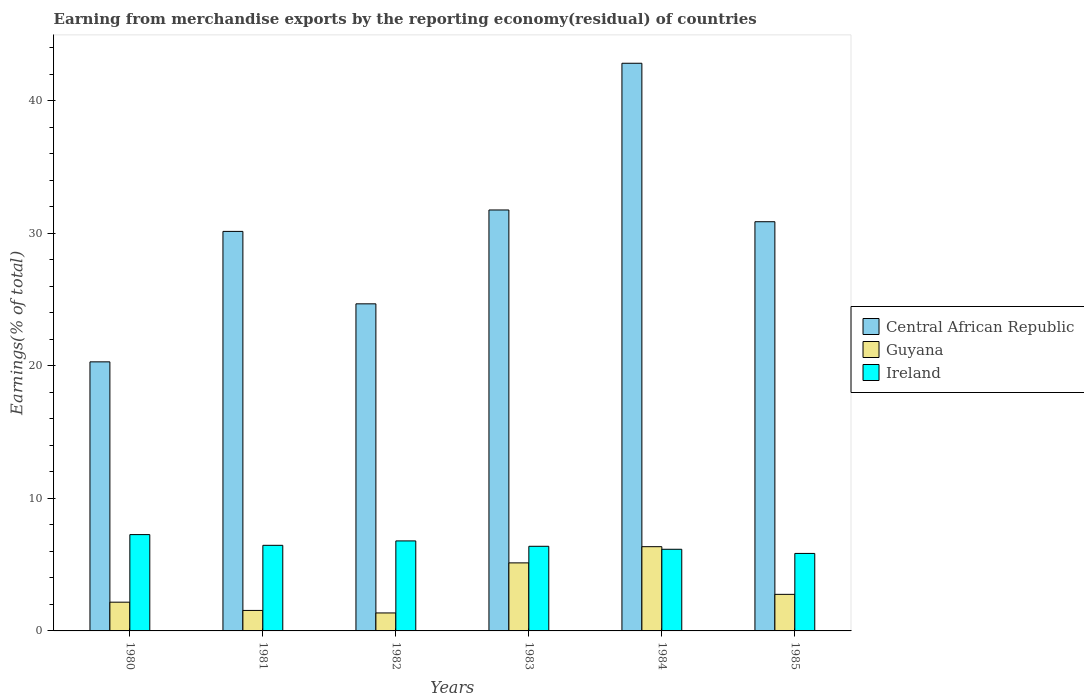Are the number of bars per tick equal to the number of legend labels?
Offer a very short reply. Yes. How many bars are there on the 4th tick from the right?
Provide a short and direct response. 3. In how many cases, is the number of bars for a given year not equal to the number of legend labels?
Keep it short and to the point. 0. What is the percentage of amount earned from merchandise exports in Ireland in 1983?
Your response must be concise. 6.38. Across all years, what is the maximum percentage of amount earned from merchandise exports in Ireland?
Make the answer very short. 7.27. Across all years, what is the minimum percentage of amount earned from merchandise exports in Ireland?
Offer a very short reply. 5.85. What is the total percentage of amount earned from merchandise exports in Ireland in the graph?
Offer a very short reply. 38.9. What is the difference between the percentage of amount earned from merchandise exports in Ireland in 1983 and that in 1984?
Provide a succinct answer. 0.22. What is the difference between the percentage of amount earned from merchandise exports in Guyana in 1985 and the percentage of amount earned from merchandise exports in Ireland in 1984?
Provide a short and direct response. -3.4. What is the average percentage of amount earned from merchandise exports in Guyana per year?
Ensure brevity in your answer.  3.22. In the year 1985, what is the difference between the percentage of amount earned from merchandise exports in Guyana and percentage of amount earned from merchandise exports in Ireland?
Provide a succinct answer. -3.09. In how many years, is the percentage of amount earned from merchandise exports in Central African Republic greater than 30 %?
Your answer should be very brief. 4. What is the ratio of the percentage of amount earned from merchandise exports in Central African Republic in 1983 to that in 1984?
Ensure brevity in your answer.  0.74. What is the difference between the highest and the second highest percentage of amount earned from merchandise exports in Ireland?
Your answer should be compact. 0.48. What is the difference between the highest and the lowest percentage of amount earned from merchandise exports in Ireland?
Your answer should be compact. 1.42. Is the sum of the percentage of amount earned from merchandise exports in Ireland in 1980 and 1983 greater than the maximum percentage of amount earned from merchandise exports in Central African Republic across all years?
Your answer should be compact. No. What does the 1st bar from the left in 1984 represents?
Provide a short and direct response. Central African Republic. What does the 2nd bar from the right in 1985 represents?
Provide a succinct answer. Guyana. How many years are there in the graph?
Your answer should be compact. 6. How many legend labels are there?
Provide a succinct answer. 3. What is the title of the graph?
Your response must be concise. Earning from merchandise exports by the reporting economy(residual) of countries. What is the label or title of the X-axis?
Offer a very short reply. Years. What is the label or title of the Y-axis?
Make the answer very short. Earnings(% of total). What is the Earnings(% of total) in Central African Republic in 1980?
Ensure brevity in your answer.  20.3. What is the Earnings(% of total) in Guyana in 1980?
Offer a terse response. 2.17. What is the Earnings(% of total) in Ireland in 1980?
Provide a short and direct response. 7.27. What is the Earnings(% of total) in Central African Republic in 1981?
Ensure brevity in your answer.  30.14. What is the Earnings(% of total) in Guyana in 1981?
Keep it short and to the point. 1.55. What is the Earnings(% of total) of Ireland in 1981?
Give a very brief answer. 6.46. What is the Earnings(% of total) in Central African Republic in 1982?
Your response must be concise. 24.67. What is the Earnings(% of total) of Guyana in 1982?
Keep it short and to the point. 1.36. What is the Earnings(% of total) in Ireland in 1982?
Your answer should be very brief. 6.79. What is the Earnings(% of total) in Central African Republic in 1983?
Give a very brief answer. 31.75. What is the Earnings(% of total) in Guyana in 1983?
Provide a succinct answer. 5.13. What is the Earnings(% of total) in Ireland in 1983?
Keep it short and to the point. 6.38. What is the Earnings(% of total) in Central African Republic in 1984?
Provide a succinct answer. 42.82. What is the Earnings(% of total) in Guyana in 1984?
Your response must be concise. 6.36. What is the Earnings(% of total) in Ireland in 1984?
Your response must be concise. 6.16. What is the Earnings(% of total) of Central African Republic in 1985?
Offer a very short reply. 30.87. What is the Earnings(% of total) of Guyana in 1985?
Your answer should be very brief. 2.76. What is the Earnings(% of total) of Ireland in 1985?
Provide a succinct answer. 5.85. Across all years, what is the maximum Earnings(% of total) of Central African Republic?
Keep it short and to the point. 42.82. Across all years, what is the maximum Earnings(% of total) in Guyana?
Provide a succinct answer. 6.36. Across all years, what is the maximum Earnings(% of total) of Ireland?
Offer a very short reply. 7.27. Across all years, what is the minimum Earnings(% of total) in Central African Republic?
Provide a succinct answer. 20.3. Across all years, what is the minimum Earnings(% of total) in Guyana?
Your answer should be compact. 1.36. Across all years, what is the minimum Earnings(% of total) of Ireland?
Keep it short and to the point. 5.85. What is the total Earnings(% of total) in Central African Republic in the graph?
Ensure brevity in your answer.  180.56. What is the total Earnings(% of total) of Guyana in the graph?
Offer a terse response. 19.32. What is the total Earnings(% of total) in Ireland in the graph?
Ensure brevity in your answer.  38.9. What is the difference between the Earnings(% of total) of Central African Republic in 1980 and that in 1981?
Provide a short and direct response. -9.84. What is the difference between the Earnings(% of total) in Guyana in 1980 and that in 1981?
Offer a very short reply. 0.62. What is the difference between the Earnings(% of total) of Ireland in 1980 and that in 1981?
Your response must be concise. 0.81. What is the difference between the Earnings(% of total) in Central African Republic in 1980 and that in 1982?
Keep it short and to the point. -4.38. What is the difference between the Earnings(% of total) in Guyana in 1980 and that in 1982?
Give a very brief answer. 0.81. What is the difference between the Earnings(% of total) in Ireland in 1980 and that in 1982?
Your response must be concise. 0.48. What is the difference between the Earnings(% of total) of Central African Republic in 1980 and that in 1983?
Your response must be concise. -11.46. What is the difference between the Earnings(% of total) in Guyana in 1980 and that in 1983?
Your response must be concise. -2.96. What is the difference between the Earnings(% of total) of Ireland in 1980 and that in 1983?
Provide a succinct answer. 0.88. What is the difference between the Earnings(% of total) in Central African Republic in 1980 and that in 1984?
Ensure brevity in your answer.  -22.52. What is the difference between the Earnings(% of total) of Guyana in 1980 and that in 1984?
Your response must be concise. -4.19. What is the difference between the Earnings(% of total) of Ireland in 1980 and that in 1984?
Give a very brief answer. 1.11. What is the difference between the Earnings(% of total) of Central African Republic in 1980 and that in 1985?
Keep it short and to the point. -10.57. What is the difference between the Earnings(% of total) of Guyana in 1980 and that in 1985?
Your response must be concise. -0.59. What is the difference between the Earnings(% of total) in Ireland in 1980 and that in 1985?
Your response must be concise. 1.42. What is the difference between the Earnings(% of total) of Central African Republic in 1981 and that in 1982?
Ensure brevity in your answer.  5.46. What is the difference between the Earnings(% of total) in Guyana in 1981 and that in 1982?
Your response must be concise. 0.19. What is the difference between the Earnings(% of total) in Ireland in 1981 and that in 1982?
Provide a succinct answer. -0.33. What is the difference between the Earnings(% of total) of Central African Republic in 1981 and that in 1983?
Give a very brief answer. -1.62. What is the difference between the Earnings(% of total) of Guyana in 1981 and that in 1983?
Your answer should be compact. -3.59. What is the difference between the Earnings(% of total) in Ireland in 1981 and that in 1983?
Your answer should be compact. 0.07. What is the difference between the Earnings(% of total) in Central African Republic in 1981 and that in 1984?
Provide a short and direct response. -12.68. What is the difference between the Earnings(% of total) in Guyana in 1981 and that in 1984?
Ensure brevity in your answer.  -4.81. What is the difference between the Earnings(% of total) of Ireland in 1981 and that in 1984?
Give a very brief answer. 0.3. What is the difference between the Earnings(% of total) of Central African Republic in 1981 and that in 1985?
Provide a succinct answer. -0.73. What is the difference between the Earnings(% of total) of Guyana in 1981 and that in 1985?
Offer a terse response. -1.21. What is the difference between the Earnings(% of total) of Ireland in 1981 and that in 1985?
Your answer should be compact. 0.61. What is the difference between the Earnings(% of total) in Central African Republic in 1982 and that in 1983?
Make the answer very short. -7.08. What is the difference between the Earnings(% of total) in Guyana in 1982 and that in 1983?
Your response must be concise. -3.78. What is the difference between the Earnings(% of total) of Ireland in 1982 and that in 1983?
Give a very brief answer. 0.41. What is the difference between the Earnings(% of total) in Central African Republic in 1982 and that in 1984?
Ensure brevity in your answer.  -18.15. What is the difference between the Earnings(% of total) of Guyana in 1982 and that in 1984?
Offer a very short reply. -5. What is the difference between the Earnings(% of total) of Ireland in 1982 and that in 1984?
Provide a succinct answer. 0.63. What is the difference between the Earnings(% of total) of Central African Republic in 1982 and that in 1985?
Offer a very short reply. -6.19. What is the difference between the Earnings(% of total) in Guyana in 1982 and that in 1985?
Offer a terse response. -1.4. What is the difference between the Earnings(% of total) in Ireland in 1982 and that in 1985?
Offer a very short reply. 0.94. What is the difference between the Earnings(% of total) in Central African Republic in 1983 and that in 1984?
Your response must be concise. -11.07. What is the difference between the Earnings(% of total) in Guyana in 1983 and that in 1984?
Offer a terse response. -1.22. What is the difference between the Earnings(% of total) in Ireland in 1983 and that in 1984?
Offer a terse response. 0.22. What is the difference between the Earnings(% of total) in Central African Republic in 1983 and that in 1985?
Provide a short and direct response. 0.89. What is the difference between the Earnings(% of total) of Guyana in 1983 and that in 1985?
Make the answer very short. 2.37. What is the difference between the Earnings(% of total) in Ireland in 1983 and that in 1985?
Your answer should be very brief. 0.54. What is the difference between the Earnings(% of total) in Central African Republic in 1984 and that in 1985?
Make the answer very short. 11.95. What is the difference between the Earnings(% of total) in Guyana in 1984 and that in 1985?
Make the answer very short. 3.6. What is the difference between the Earnings(% of total) of Ireland in 1984 and that in 1985?
Provide a short and direct response. 0.31. What is the difference between the Earnings(% of total) in Central African Republic in 1980 and the Earnings(% of total) in Guyana in 1981?
Give a very brief answer. 18.75. What is the difference between the Earnings(% of total) of Central African Republic in 1980 and the Earnings(% of total) of Ireland in 1981?
Keep it short and to the point. 13.84. What is the difference between the Earnings(% of total) in Guyana in 1980 and the Earnings(% of total) in Ireland in 1981?
Offer a terse response. -4.29. What is the difference between the Earnings(% of total) in Central African Republic in 1980 and the Earnings(% of total) in Guyana in 1982?
Offer a terse response. 18.94. What is the difference between the Earnings(% of total) in Central African Republic in 1980 and the Earnings(% of total) in Ireland in 1982?
Offer a terse response. 13.51. What is the difference between the Earnings(% of total) in Guyana in 1980 and the Earnings(% of total) in Ireland in 1982?
Your answer should be compact. -4.62. What is the difference between the Earnings(% of total) of Central African Republic in 1980 and the Earnings(% of total) of Guyana in 1983?
Ensure brevity in your answer.  15.17. What is the difference between the Earnings(% of total) in Central African Republic in 1980 and the Earnings(% of total) in Ireland in 1983?
Your answer should be very brief. 13.91. What is the difference between the Earnings(% of total) in Guyana in 1980 and the Earnings(% of total) in Ireland in 1983?
Your answer should be compact. -4.22. What is the difference between the Earnings(% of total) in Central African Republic in 1980 and the Earnings(% of total) in Guyana in 1984?
Provide a short and direct response. 13.94. What is the difference between the Earnings(% of total) of Central African Republic in 1980 and the Earnings(% of total) of Ireland in 1984?
Offer a very short reply. 14.14. What is the difference between the Earnings(% of total) in Guyana in 1980 and the Earnings(% of total) in Ireland in 1984?
Ensure brevity in your answer.  -3.99. What is the difference between the Earnings(% of total) in Central African Republic in 1980 and the Earnings(% of total) in Guyana in 1985?
Your answer should be compact. 17.54. What is the difference between the Earnings(% of total) of Central African Republic in 1980 and the Earnings(% of total) of Ireland in 1985?
Ensure brevity in your answer.  14.45. What is the difference between the Earnings(% of total) of Guyana in 1980 and the Earnings(% of total) of Ireland in 1985?
Offer a terse response. -3.68. What is the difference between the Earnings(% of total) in Central African Republic in 1981 and the Earnings(% of total) in Guyana in 1982?
Offer a very short reply. 28.78. What is the difference between the Earnings(% of total) of Central African Republic in 1981 and the Earnings(% of total) of Ireland in 1982?
Offer a very short reply. 23.35. What is the difference between the Earnings(% of total) in Guyana in 1981 and the Earnings(% of total) in Ireland in 1982?
Your answer should be compact. -5.24. What is the difference between the Earnings(% of total) of Central African Republic in 1981 and the Earnings(% of total) of Guyana in 1983?
Offer a very short reply. 25.01. What is the difference between the Earnings(% of total) in Central African Republic in 1981 and the Earnings(% of total) in Ireland in 1983?
Offer a very short reply. 23.75. What is the difference between the Earnings(% of total) of Guyana in 1981 and the Earnings(% of total) of Ireland in 1983?
Your response must be concise. -4.84. What is the difference between the Earnings(% of total) in Central African Republic in 1981 and the Earnings(% of total) in Guyana in 1984?
Provide a succinct answer. 23.78. What is the difference between the Earnings(% of total) of Central African Republic in 1981 and the Earnings(% of total) of Ireland in 1984?
Your answer should be very brief. 23.98. What is the difference between the Earnings(% of total) of Guyana in 1981 and the Earnings(% of total) of Ireland in 1984?
Your answer should be very brief. -4.61. What is the difference between the Earnings(% of total) of Central African Republic in 1981 and the Earnings(% of total) of Guyana in 1985?
Your answer should be very brief. 27.38. What is the difference between the Earnings(% of total) in Central African Republic in 1981 and the Earnings(% of total) in Ireland in 1985?
Your answer should be very brief. 24.29. What is the difference between the Earnings(% of total) of Guyana in 1981 and the Earnings(% of total) of Ireland in 1985?
Keep it short and to the point. -4.3. What is the difference between the Earnings(% of total) in Central African Republic in 1982 and the Earnings(% of total) in Guyana in 1983?
Give a very brief answer. 19.54. What is the difference between the Earnings(% of total) of Central African Republic in 1982 and the Earnings(% of total) of Ireland in 1983?
Offer a terse response. 18.29. What is the difference between the Earnings(% of total) in Guyana in 1982 and the Earnings(% of total) in Ireland in 1983?
Ensure brevity in your answer.  -5.03. What is the difference between the Earnings(% of total) in Central African Republic in 1982 and the Earnings(% of total) in Guyana in 1984?
Provide a short and direct response. 18.32. What is the difference between the Earnings(% of total) in Central African Republic in 1982 and the Earnings(% of total) in Ireland in 1984?
Ensure brevity in your answer.  18.51. What is the difference between the Earnings(% of total) in Guyana in 1982 and the Earnings(% of total) in Ireland in 1984?
Offer a terse response. -4.8. What is the difference between the Earnings(% of total) in Central African Republic in 1982 and the Earnings(% of total) in Guyana in 1985?
Offer a terse response. 21.92. What is the difference between the Earnings(% of total) of Central African Republic in 1982 and the Earnings(% of total) of Ireland in 1985?
Your answer should be very brief. 18.83. What is the difference between the Earnings(% of total) in Guyana in 1982 and the Earnings(% of total) in Ireland in 1985?
Ensure brevity in your answer.  -4.49. What is the difference between the Earnings(% of total) in Central African Republic in 1983 and the Earnings(% of total) in Guyana in 1984?
Provide a short and direct response. 25.4. What is the difference between the Earnings(% of total) in Central African Republic in 1983 and the Earnings(% of total) in Ireland in 1984?
Provide a short and direct response. 25.6. What is the difference between the Earnings(% of total) of Guyana in 1983 and the Earnings(% of total) of Ireland in 1984?
Ensure brevity in your answer.  -1.03. What is the difference between the Earnings(% of total) of Central African Republic in 1983 and the Earnings(% of total) of Guyana in 1985?
Offer a very short reply. 29. What is the difference between the Earnings(% of total) in Central African Republic in 1983 and the Earnings(% of total) in Ireland in 1985?
Give a very brief answer. 25.91. What is the difference between the Earnings(% of total) of Guyana in 1983 and the Earnings(% of total) of Ireland in 1985?
Ensure brevity in your answer.  -0.71. What is the difference between the Earnings(% of total) of Central African Republic in 1984 and the Earnings(% of total) of Guyana in 1985?
Give a very brief answer. 40.06. What is the difference between the Earnings(% of total) of Central African Republic in 1984 and the Earnings(% of total) of Ireland in 1985?
Provide a short and direct response. 36.98. What is the difference between the Earnings(% of total) of Guyana in 1984 and the Earnings(% of total) of Ireland in 1985?
Provide a succinct answer. 0.51. What is the average Earnings(% of total) in Central African Republic per year?
Offer a terse response. 30.09. What is the average Earnings(% of total) in Guyana per year?
Your answer should be compact. 3.22. What is the average Earnings(% of total) in Ireland per year?
Offer a terse response. 6.48. In the year 1980, what is the difference between the Earnings(% of total) in Central African Republic and Earnings(% of total) in Guyana?
Keep it short and to the point. 18.13. In the year 1980, what is the difference between the Earnings(% of total) in Central African Republic and Earnings(% of total) in Ireland?
Provide a short and direct response. 13.03. In the year 1980, what is the difference between the Earnings(% of total) of Guyana and Earnings(% of total) of Ireland?
Make the answer very short. -5.1. In the year 1981, what is the difference between the Earnings(% of total) in Central African Republic and Earnings(% of total) in Guyana?
Your answer should be very brief. 28.59. In the year 1981, what is the difference between the Earnings(% of total) in Central African Republic and Earnings(% of total) in Ireland?
Make the answer very short. 23.68. In the year 1981, what is the difference between the Earnings(% of total) in Guyana and Earnings(% of total) in Ireland?
Your answer should be compact. -4.91. In the year 1982, what is the difference between the Earnings(% of total) in Central African Republic and Earnings(% of total) in Guyana?
Your response must be concise. 23.32. In the year 1982, what is the difference between the Earnings(% of total) in Central African Republic and Earnings(% of total) in Ireland?
Your answer should be very brief. 17.88. In the year 1982, what is the difference between the Earnings(% of total) of Guyana and Earnings(% of total) of Ireland?
Your response must be concise. -5.43. In the year 1983, what is the difference between the Earnings(% of total) of Central African Republic and Earnings(% of total) of Guyana?
Your answer should be very brief. 26.62. In the year 1983, what is the difference between the Earnings(% of total) in Central African Republic and Earnings(% of total) in Ireland?
Your response must be concise. 25.37. In the year 1983, what is the difference between the Earnings(% of total) of Guyana and Earnings(% of total) of Ireland?
Offer a very short reply. -1.25. In the year 1984, what is the difference between the Earnings(% of total) in Central African Republic and Earnings(% of total) in Guyana?
Your answer should be very brief. 36.47. In the year 1984, what is the difference between the Earnings(% of total) in Central African Republic and Earnings(% of total) in Ireland?
Ensure brevity in your answer.  36.66. In the year 1984, what is the difference between the Earnings(% of total) of Guyana and Earnings(% of total) of Ireland?
Keep it short and to the point. 0.2. In the year 1985, what is the difference between the Earnings(% of total) of Central African Republic and Earnings(% of total) of Guyana?
Make the answer very short. 28.11. In the year 1985, what is the difference between the Earnings(% of total) of Central African Republic and Earnings(% of total) of Ireland?
Your response must be concise. 25.02. In the year 1985, what is the difference between the Earnings(% of total) in Guyana and Earnings(% of total) in Ireland?
Offer a terse response. -3.09. What is the ratio of the Earnings(% of total) of Central African Republic in 1980 to that in 1981?
Provide a succinct answer. 0.67. What is the ratio of the Earnings(% of total) of Guyana in 1980 to that in 1981?
Give a very brief answer. 1.4. What is the ratio of the Earnings(% of total) of Ireland in 1980 to that in 1981?
Your answer should be compact. 1.13. What is the ratio of the Earnings(% of total) in Central African Republic in 1980 to that in 1982?
Ensure brevity in your answer.  0.82. What is the ratio of the Earnings(% of total) in Guyana in 1980 to that in 1982?
Your answer should be compact. 1.6. What is the ratio of the Earnings(% of total) of Ireland in 1980 to that in 1982?
Provide a succinct answer. 1.07. What is the ratio of the Earnings(% of total) of Central African Republic in 1980 to that in 1983?
Your answer should be compact. 0.64. What is the ratio of the Earnings(% of total) in Guyana in 1980 to that in 1983?
Offer a very short reply. 0.42. What is the ratio of the Earnings(% of total) in Ireland in 1980 to that in 1983?
Offer a very short reply. 1.14. What is the ratio of the Earnings(% of total) of Central African Republic in 1980 to that in 1984?
Your answer should be very brief. 0.47. What is the ratio of the Earnings(% of total) in Guyana in 1980 to that in 1984?
Offer a very short reply. 0.34. What is the ratio of the Earnings(% of total) in Ireland in 1980 to that in 1984?
Provide a succinct answer. 1.18. What is the ratio of the Earnings(% of total) in Central African Republic in 1980 to that in 1985?
Ensure brevity in your answer.  0.66. What is the ratio of the Earnings(% of total) in Guyana in 1980 to that in 1985?
Provide a succinct answer. 0.79. What is the ratio of the Earnings(% of total) in Ireland in 1980 to that in 1985?
Provide a succinct answer. 1.24. What is the ratio of the Earnings(% of total) of Central African Republic in 1981 to that in 1982?
Provide a short and direct response. 1.22. What is the ratio of the Earnings(% of total) of Guyana in 1981 to that in 1982?
Provide a short and direct response. 1.14. What is the ratio of the Earnings(% of total) in Ireland in 1981 to that in 1982?
Your response must be concise. 0.95. What is the ratio of the Earnings(% of total) in Central African Republic in 1981 to that in 1983?
Your response must be concise. 0.95. What is the ratio of the Earnings(% of total) of Guyana in 1981 to that in 1983?
Provide a short and direct response. 0.3. What is the ratio of the Earnings(% of total) of Ireland in 1981 to that in 1983?
Provide a succinct answer. 1.01. What is the ratio of the Earnings(% of total) in Central African Republic in 1981 to that in 1984?
Offer a very short reply. 0.7. What is the ratio of the Earnings(% of total) of Guyana in 1981 to that in 1984?
Your answer should be very brief. 0.24. What is the ratio of the Earnings(% of total) of Ireland in 1981 to that in 1984?
Your answer should be very brief. 1.05. What is the ratio of the Earnings(% of total) in Central African Republic in 1981 to that in 1985?
Ensure brevity in your answer.  0.98. What is the ratio of the Earnings(% of total) of Guyana in 1981 to that in 1985?
Ensure brevity in your answer.  0.56. What is the ratio of the Earnings(% of total) of Ireland in 1981 to that in 1985?
Offer a terse response. 1.1. What is the ratio of the Earnings(% of total) in Central African Republic in 1982 to that in 1983?
Offer a very short reply. 0.78. What is the ratio of the Earnings(% of total) of Guyana in 1982 to that in 1983?
Offer a very short reply. 0.26. What is the ratio of the Earnings(% of total) of Ireland in 1982 to that in 1983?
Provide a short and direct response. 1.06. What is the ratio of the Earnings(% of total) of Central African Republic in 1982 to that in 1984?
Make the answer very short. 0.58. What is the ratio of the Earnings(% of total) in Guyana in 1982 to that in 1984?
Your response must be concise. 0.21. What is the ratio of the Earnings(% of total) in Ireland in 1982 to that in 1984?
Provide a short and direct response. 1.1. What is the ratio of the Earnings(% of total) in Central African Republic in 1982 to that in 1985?
Your answer should be compact. 0.8. What is the ratio of the Earnings(% of total) of Guyana in 1982 to that in 1985?
Make the answer very short. 0.49. What is the ratio of the Earnings(% of total) of Ireland in 1982 to that in 1985?
Ensure brevity in your answer.  1.16. What is the ratio of the Earnings(% of total) of Central African Republic in 1983 to that in 1984?
Provide a succinct answer. 0.74. What is the ratio of the Earnings(% of total) in Guyana in 1983 to that in 1984?
Offer a very short reply. 0.81. What is the ratio of the Earnings(% of total) of Ireland in 1983 to that in 1984?
Offer a very short reply. 1.04. What is the ratio of the Earnings(% of total) in Central African Republic in 1983 to that in 1985?
Give a very brief answer. 1.03. What is the ratio of the Earnings(% of total) in Guyana in 1983 to that in 1985?
Give a very brief answer. 1.86. What is the ratio of the Earnings(% of total) in Ireland in 1983 to that in 1985?
Your response must be concise. 1.09. What is the ratio of the Earnings(% of total) of Central African Republic in 1984 to that in 1985?
Give a very brief answer. 1.39. What is the ratio of the Earnings(% of total) of Guyana in 1984 to that in 1985?
Give a very brief answer. 2.3. What is the ratio of the Earnings(% of total) of Ireland in 1984 to that in 1985?
Make the answer very short. 1.05. What is the difference between the highest and the second highest Earnings(% of total) in Central African Republic?
Provide a short and direct response. 11.07. What is the difference between the highest and the second highest Earnings(% of total) in Guyana?
Your answer should be very brief. 1.22. What is the difference between the highest and the second highest Earnings(% of total) in Ireland?
Provide a succinct answer. 0.48. What is the difference between the highest and the lowest Earnings(% of total) of Central African Republic?
Give a very brief answer. 22.52. What is the difference between the highest and the lowest Earnings(% of total) of Guyana?
Your answer should be very brief. 5. What is the difference between the highest and the lowest Earnings(% of total) of Ireland?
Your answer should be very brief. 1.42. 